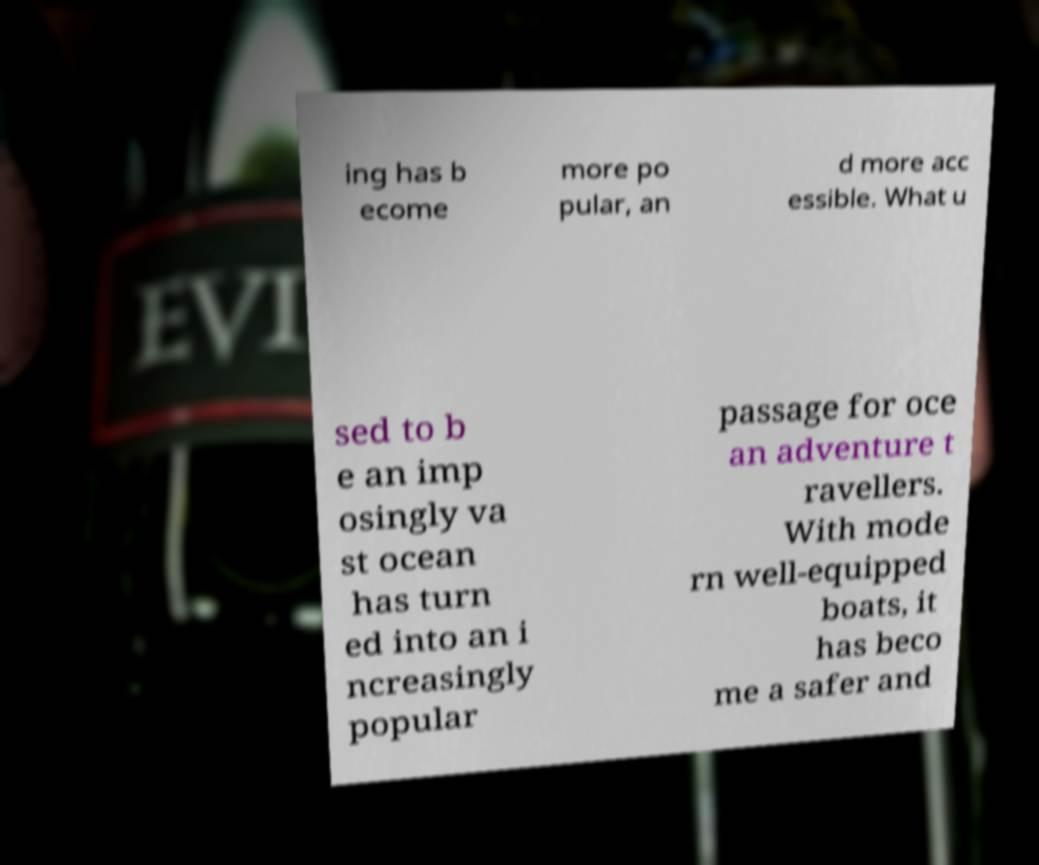I need the written content from this picture converted into text. Can you do that? ing has b ecome more po pular, an d more acc essible. What u sed to b e an imp osingly va st ocean has turn ed into an i ncreasingly popular passage for oce an adventure t ravellers. With mode rn well-equipped boats, it has beco me a safer and 